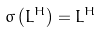<formula> <loc_0><loc_0><loc_500><loc_500>\sigma \left ( L ^ { H } \right ) = L ^ { H }</formula> 